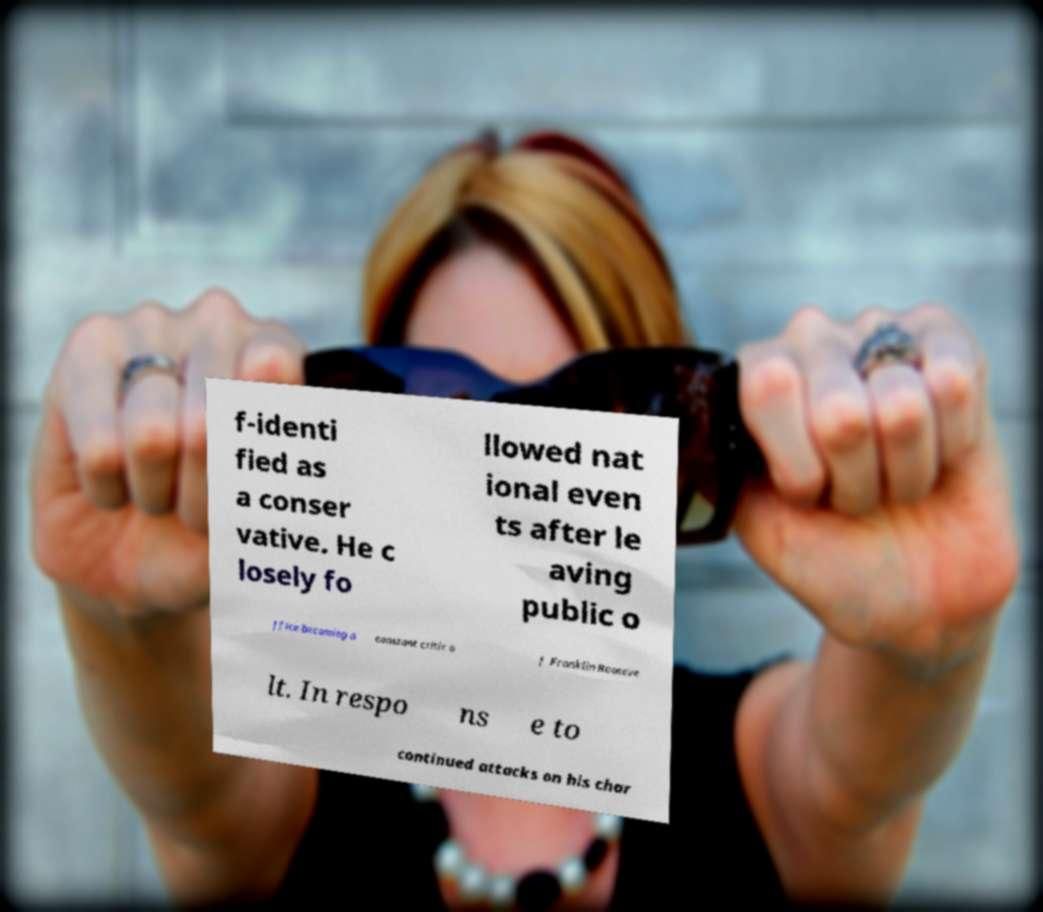Could you extract and type out the text from this image? f-identi fied as a conser vative. He c losely fo llowed nat ional even ts after le aving public o ffice becoming a constant critic o f Franklin Rooseve lt. In respo ns e to continued attacks on his char 